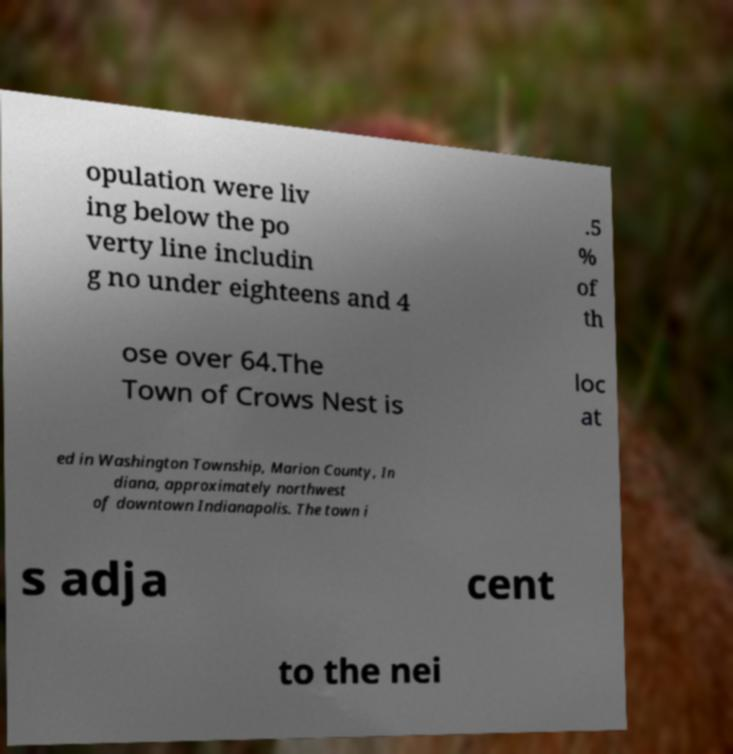Please read and relay the text visible in this image. What does it say? opulation were liv ing below the po verty line includin g no under eighteens and 4 .5 % of th ose over 64.The Town of Crows Nest is loc at ed in Washington Township, Marion County, In diana, approximately northwest of downtown Indianapolis. The town i s adja cent to the nei 